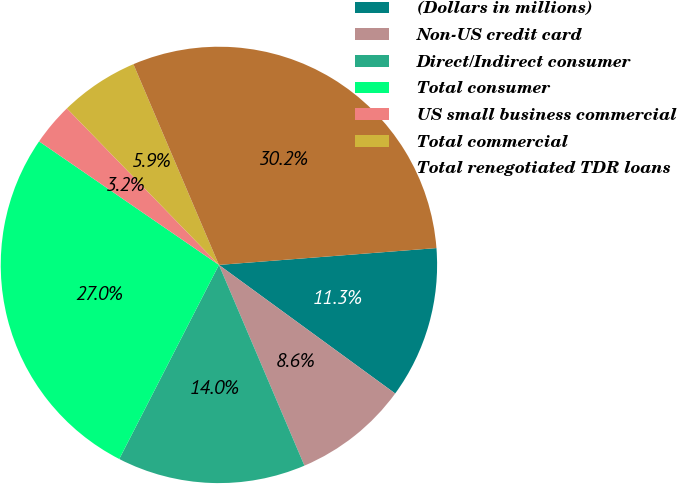<chart> <loc_0><loc_0><loc_500><loc_500><pie_chart><fcel>(Dollars in millions)<fcel>Non-US credit card<fcel>Direct/Indirect consumer<fcel>Total consumer<fcel>US small business commercial<fcel>Total commercial<fcel>Total renegotiated TDR loans<nl><fcel>11.26%<fcel>8.56%<fcel>13.96%<fcel>27.03%<fcel>3.15%<fcel>5.86%<fcel>30.18%<nl></chart> 